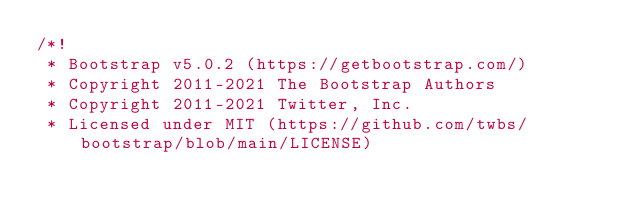<code> <loc_0><loc_0><loc_500><loc_500><_CSS_>/*!
 * Bootstrap v5.0.2 (https://getbootstrap.com/)
 * Copyright 2011-2021 The Bootstrap Authors
 * Copyright 2011-2021 Twitter, Inc.
 * Licensed under MIT (https://github.com/twbs/bootstrap/blob/main/LICENSE)</code> 